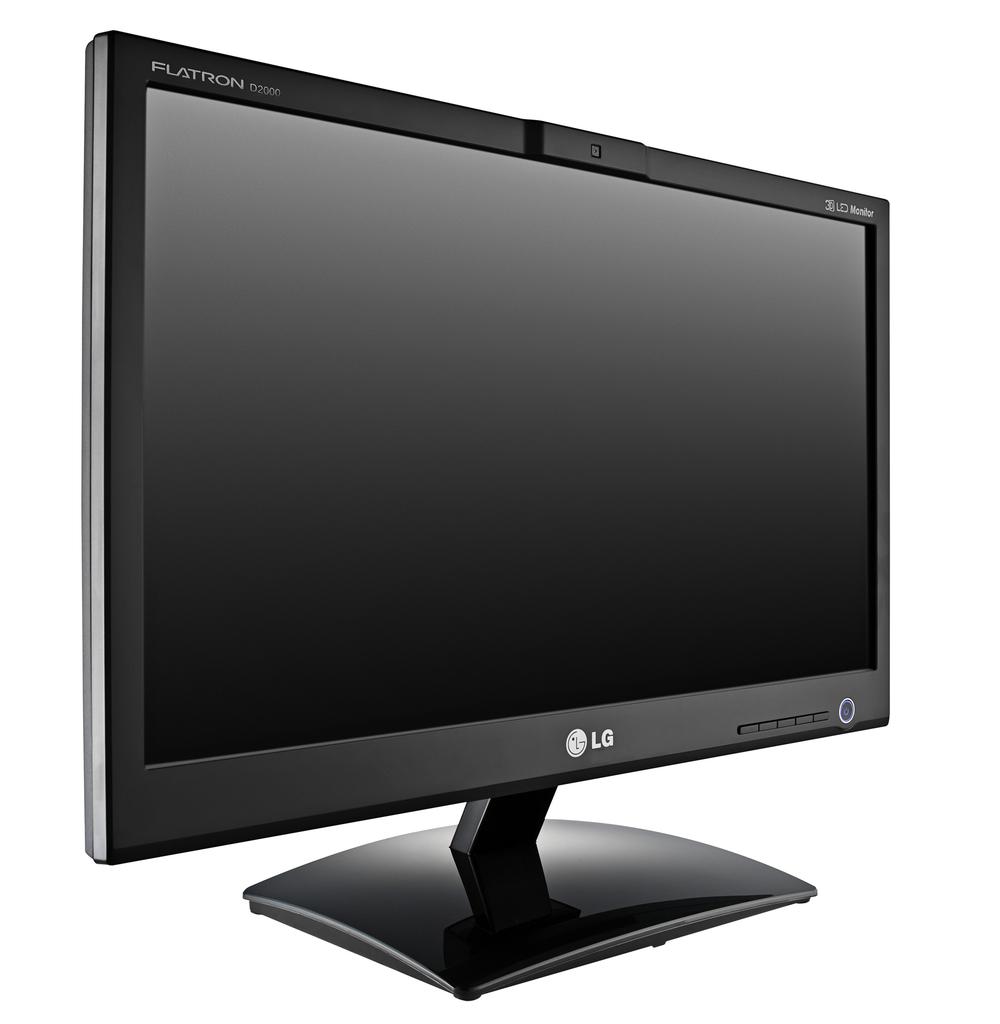What brand of computer is that?
Offer a very short reply. Lg. What model is this monitor?
Your response must be concise. Lg. 